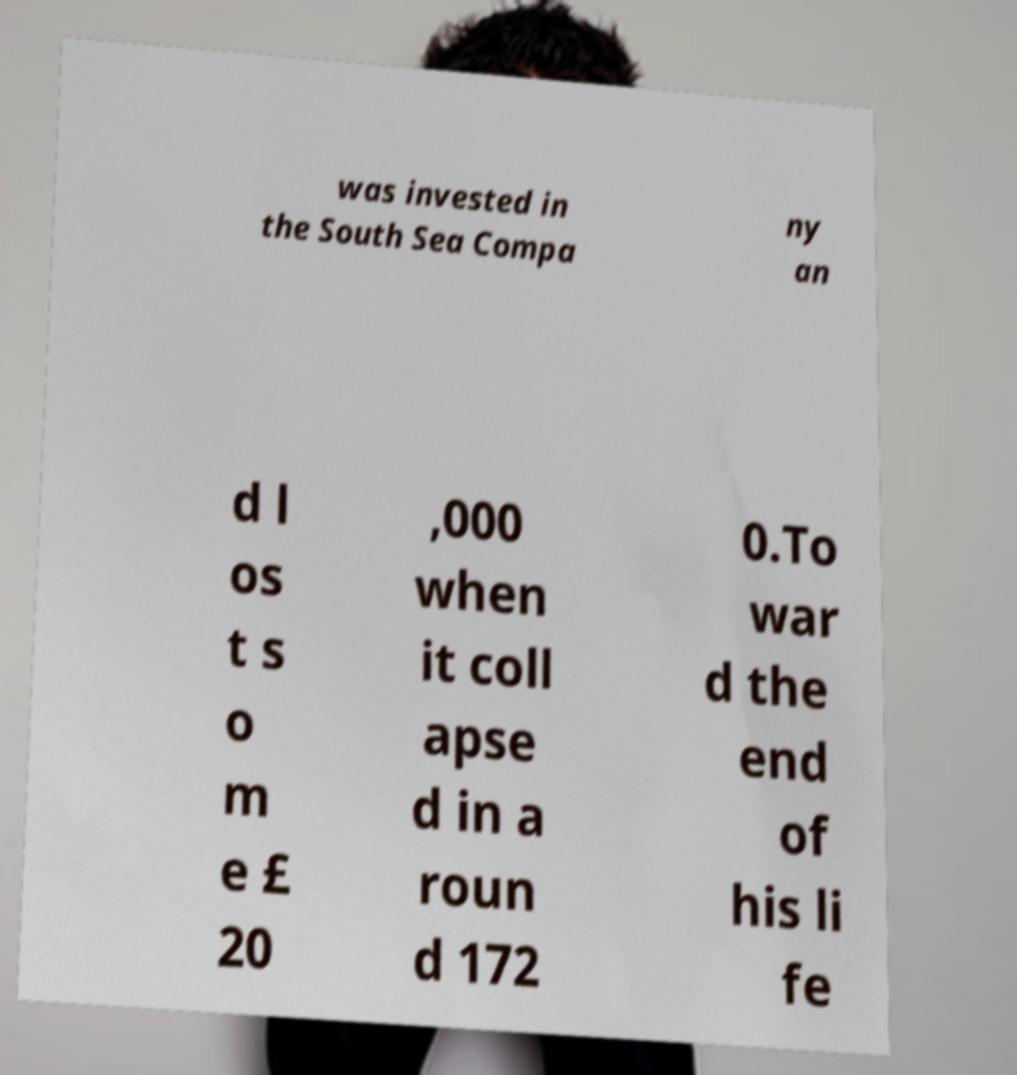Could you extract and type out the text from this image? was invested in the South Sea Compa ny an d l os t s o m e £ 20 ,000 when it coll apse d in a roun d 172 0.To war d the end of his li fe 